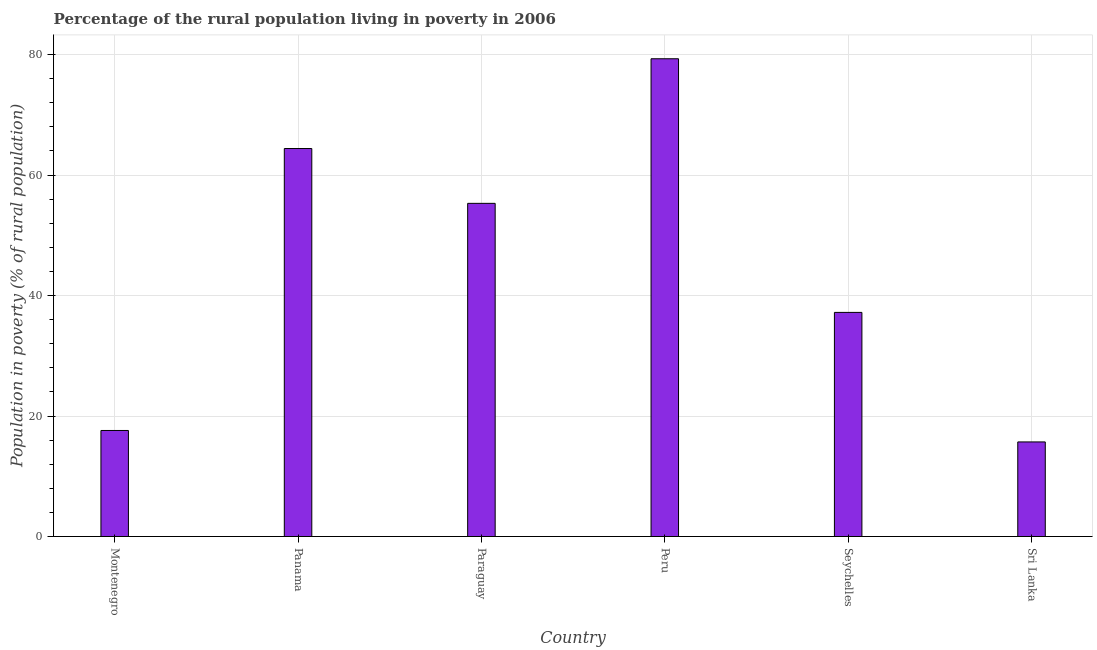Does the graph contain any zero values?
Offer a very short reply. No. What is the title of the graph?
Keep it short and to the point. Percentage of the rural population living in poverty in 2006. What is the label or title of the X-axis?
Give a very brief answer. Country. What is the label or title of the Y-axis?
Provide a succinct answer. Population in poverty (% of rural population). What is the percentage of rural population living below poverty line in Seychelles?
Your response must be concise. 37.2. Across all countries, what is the maximum percentage of rural population living below poverty line?
Offer a very short reply. 79.3. In which country was the percentage of rural population living below poverty line maximum?
Your response must be concise. Peru. In which country was the percentage of rural population living below poverty line minimum?
Your answer should be very brief. Sri Lanka. What is the sum of the percentage of rural population living below poverty line?
Offer a very short reply. 269.5. What is the average percentage of rural population living below poverty line per country?
Your answer should be compact. 44.92. What is the median percentage of rural population living below poverty line?
Your answer should be very brief. 46.25. What is the ratio of the percentage of rural population living below poverty line in Panama to that in Sri Lanka?
Provide a short and direct response. 4.1. Is the percentage of rural population living below poverty line in Montenegro less than that in Sri Lanka?
Provide a succinct answer. No. What is the difference between the highest and the second highest percentage of rural population living below poverty line?
Offer a terse response. 14.9. What is the difference between the highest and the lowest percentage of rural population living below poverty line?
Your answer should be compact. 63.6. In how many countries, is the percentage of rural population living below poverty line greater than the average percentage of rural population living below poverty line taken over all countries?
Keep it short and to the point. 3. Are all the bars in the graph horizontal?
Ensure brevity in your answer.  No. How many countries are there in the graph?
Give a very brief answer. 6. What is the Population in poverty (% of rural population) of Montenegro?
Ensure brevity in your answer.  17.6. What is the Population in poverty (% of rural population) in Panama?
Offer a terse response. 64.4. What is the Population in poverty (% of rural population) of Paraguay?
Your answer should be very brief. 55.3. What is the Population in poverty (% of rural population) of Peru?
Offer a terse response. 79.3. What is the Population in poverty (% of rural population) in Seychelles?
Make the answer very short. 37.2. What is the Population in poverty (% of rural population) in Sri Lanka?
Ensure brevity in your answer.  15.7. What is the difference between the Population in poverty (% of rural population) in Montenegro and Panama?
Provide a short and direct response. -46.8. What is the difference between the Population in poverty (% of rural population) in Montenegro and Paraguay?
Make the answer very short. -37.7. What is the difference between the Population in poverty (% of rural population) in Montenegro and Peru?
Keep it short and to the point. -61.7. What is the difference between the Population in poverty (% of rural population) in Montenegro and Seychelles?
Provide a succinct answer. -19.6. What is the difference between the Population in poverty (% of rural population) in Panama and Peru?
Provide a short and direct response. -14.9. What is the difference between the Population in poverty (% of rural population) in Panama and Seychelles?
Make the answer very short. 27.2. What is the difference between the Population in poverty (% of rural population) in Panama and Sri Lanka?
Provide a short and direct response. 48.7. What is the difference between the Population in poverty (% of rural population) in Paraguay and Peru?
Your response must be concise. -24. What is the difference between the Population in poverty (% of rural population) in Paraguay and Seychelles?
Your answer should be very brief. 18.1. What is the difference between the Population in poverty (% of rural population) in Paraguay and Sri Lanka?
Offer a very short reply. 39.6. What is the difference between the Population in poverty (% of rural population) in Peru and Seychelles?
Offer a terse response. 42.1. What is the difference between the Population in poverty (% of rural population) in Peru and Sri Lanka?
Provide a short and direct response. 63.6. What is the difference between the Population in poverty (% of rural population) in Seychelles and Sri Lanka?
Keep it short and to the point. 21.5. What is the ratio of the Population in poverty (% of rural population) in Montenegro to that in Panama?
Your answer should be very brief. 0.27. What is the ratio of the Population in poverty (% of rural population) in Montenegro to that in Paraguay?
Provide a succinct answer. 0.32. What is the ratio of the Population in poverty (% of rural population) in Montenegro to that in Peru?
Your answer should be compact. 0.22. What is the ratio of the Population in poverty (% of rural population) in Montenegro to that in Seychelles?
Offer a terse response. 0.47. What is the ratio of the Population in poverty (% of rural population) in Montenegro to that in Sri Lanka?
Offer a terse response. 1.12. What is the ratio of the Population in poverty (% of rural population) in Panama to that in Paraguay?
Give a very brief answer. 1.17. What is the ratio of the Population in poverty (% of rural population) in Panama to that in Peru?
Provide a short and direct response. 0.81. What is the ratio of the Population in poverty (% of rural population) in Panama to that in Seychelles?
Ensure brevity in your answer.  1.73. What is the ratio of the Population in poverty (% of rural population) in Panama to that in Sri Lanka?
Your answer should be compact. 4.1. What is the ratio of the Population in poverty (% of rural population) in Paraguay to that in Peru?
Your answer should be very brief. 0.7. What is the ratio of the Population in poverty (% of rural population) in Paraguay to that in Seychelles?
Your response must be concise. 1.49. What is the ratio of the Population in poverty (% of rural population) in Paraguay to that in Sri Lanka?
Your answer should be compact. 3.52. What is the ratio of the Population in poverty (% of rural population) in Peru to that in Seychelles?
Offer a very short reply. 2.13. What is the ratio of the Population in poverty (% of rural population) in Peru to that in Sri Lanka?
Your answer should be compact. 5.05. What is the ratio of the Population in poverty (% of rural population) in Seychelles to that in Sri Lanka?
Your answer should be compact. 2.37. 